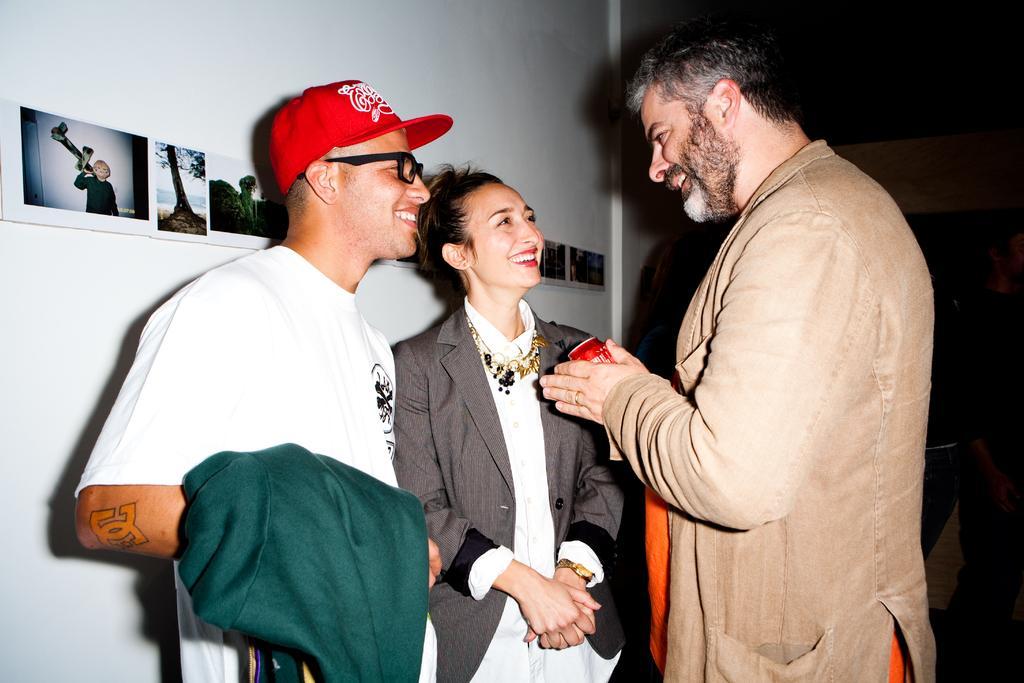How would you summarize this image in a sentence or two? The picture consists of three people where there are two men and a woman, they are having smiley faces. On the left it is a wall, on the wall there are photographs. On the right it is dark. 